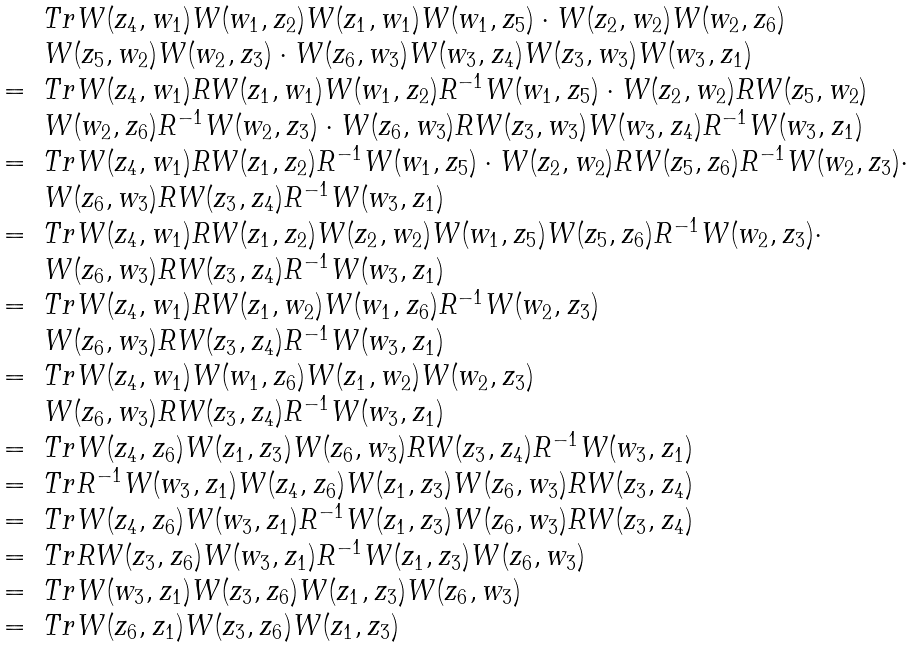<formula> <loc_0><loc_0><loc_500><loc_500>\begin{array} { r l } & T r W ( z _ { 4 } , w _ { 1 } ) W ( w _ { 1 } , z _ { 2 } ) W ( z _ { 1 } , w _ { 1 } ) W ( w _ { 1 } , z _ { 5 } ) \cdot W ( z _ { 2 } , w _ { 2 } ) W ( w _ { 2 } , z _ { 6 } ) \\ & W ( z _ { 5 } , w _ { 2 } ) W ( w _ { 2 } , z _ { 3 } ) \cdot W ( z _ { 6 } , w _ { 3 } ) W ( w _ { 3 } , z _ { 4 } ) W ( z _ { 3 } , w _ { 3 } ) W ( w _ { 3 } , z _ { 1 } ) \\ = & T r W ( z _ { 4 } , w _ { 1 } ) R W ( z _ { 1 } , w _ { 1 } ) W ( w _ { 1 } , z _ { 2 } ) R ^ { - 1 } W ( w _ { 1 } , z _ { 5 } ) \cdot W ( z _ { 2 } , w _ { 2 } ) R W ( z _ { 5 } , w _ { 2 } ) \\ & W ( w _ { 2 } , z _ { 6 } ) R ^ { - 1 } W ( w _ { 2 } , z _ { 3 } ) \cdot W ( z _ { 6 } , w _ { 3 } ) R W ( z _ { 3 } , w _ { 3 } ) W ( w _ { 3 } , z _ { 4 } ) R ^ { - 1 } W ( w _ { 3 } , z _ { 1 } ) \\ = & T r W ( z _ { 4 } , w _ { 1 } ) R W ( z _ { 1 } , z _ { 2 } ) R ^ { - 1 } W ( w _ { 1 } , z _ { 5 } ) \cdot W ( z _ { 2 } , w _ { 2 } ) R W ( z _ { 5 } , z _ { 6 } ) R ^ { - 1 } W ( w _ { 2 } , z _ { 3 } ) \cdot \\ & W ( z _ { 6 } , w _ { 3 } ) R W ( z _ { 3 } , z _ { 4 } ) R ^ { - 1 } W ( w _ { 3 } , z _ { 1 } ) \\ = & T r W ( z _ { 4 } , w _ { 1 } ) R W ( z _ { 1 } , z _ { 2 } ) W ( z _ { 2 } , w _ { 2 } ) W ( w _ { 1 } , z _ { 5 } ) W ( z _ { 5 } , z _ { 6 } ) R ^ { - 1 } W ( w _ { 2 } , z _ { 3 } ) \cdot \\ & W ( z _ { 6 } , w _ { 3 } ) R W ( z _ { 3 } , z _ { 4 } ) R ^ { - 1 } W ( w _ { 3 } , z _ { 1 } ) \\ = & T r W ( z _ { 4 } , w _ { 1 } ) R W ( z _ { 1 } , w _ { 2 } ) W ( w _ { 1 } , z _ { 6 } ) R ^ { - 1 } W ( w _ { 2 } , z _ { 3 } ) \\ & W ( z _ { 6 } , w _ { 3 } ) R W ( z _ { 3 } , z _ { 4 } ) R ^ { - 1 } W ( w _ { 3 } , z _ { 1 } ) \\ = & T r W ( z _ { 4 } , w _ { 1 } ) W ( w _ { 1 } , z _ { 6 } ) W ( z _ { 1 } , w _ { 2 } ) W ( w _ { 2 } , z _ { 3 } ) \\ & W ( z _ { 6 } , w _ { 3 } ) R W ( z _ { 3 } , z _ { 4 } ) R ^ { - 1 } W ( w _ { 3 } , z _ { 1 } ) \\ = & T r W ( z _ { 4 } , z _ { 6 } ) W ( z _ { 1 } , z _ { 3 } ) W ( z _ { 6 } , w _ { 3 } ) R W ( z _ { 3 } , z _ { 4 } ) R ^ { - 1 } W ( w _ { 3 } , z _ { 1 } ) \\ = & T r R ^ { - 1 } W ( w _ { 3 } , z _ { 1 } ) W ( z _ { 4 } , z _ { 6 } ) W ( z _ { 1 } , z _ { 3 } ) W ( z _ { 6 } , w _ { 3 } ) R W ( z _ { 3 } , z _ { 4 } ) \\ = & T r W ( z _ { 4 } , z _ { 6 } ) W ( w _ { 3 } , z _ { 1 } ) R ^ { - 1 } W ( z _ { 1 } , z _ { 3 } ) W ( z _ { 6 } , w _ { 3 } ) R W ( z _ { 3 } , z _ { 4 } ) \\ = & T r R W ( z _ { 3 } , z _ { 6 } ) W ( w _ { 3 } , z _ { 1 } ) R ^ { - 1 } W ( z _ { 1 } , z _ { 3 } ) W ( z _ { 6 } , w _ { 3 } ) \\ = & T r W ( w _ { 3 } , z _ { 1 } ) W ( z _ { 3 } , z _ { 6 } ) W ( z _ { 1 } , z _ { 3 } ) W ( z _ { 6 } , w _ { 3 } ) \\ = & T r W ( z _ { 6 } , z _ { 1 } ) W ( z _ { 3 } , z _ { 6 } ) W ( z _ { 1 } , z _ { 3 } ) \end{array}</formula> 